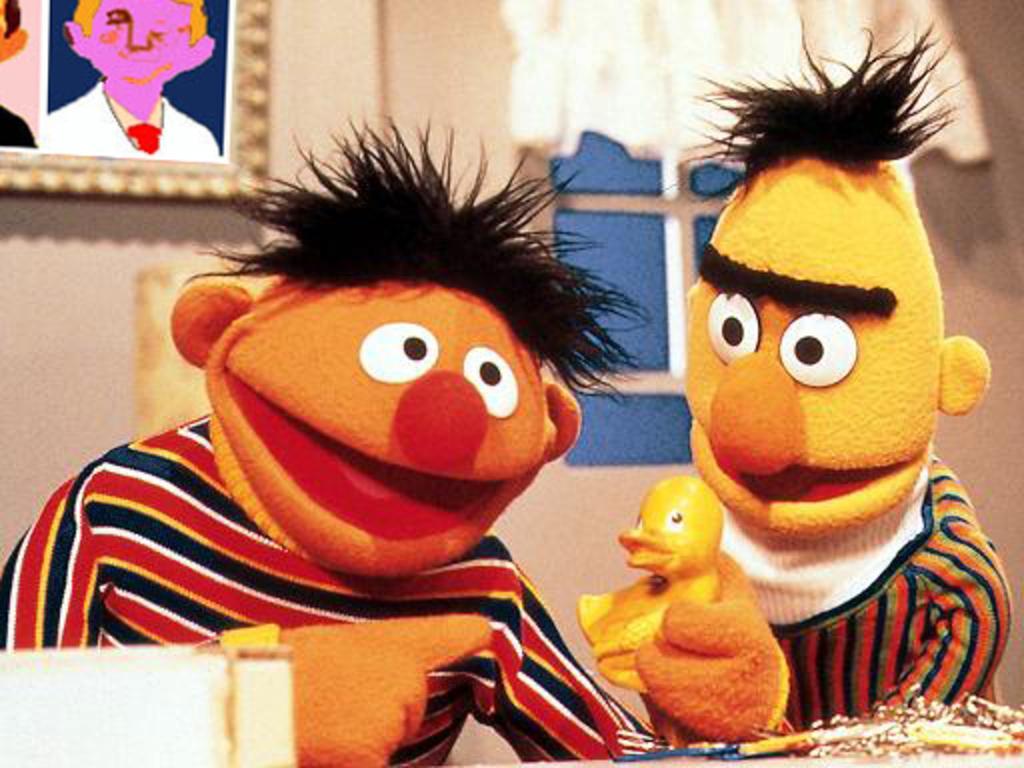How would you summarize this image in a sentence or two? In this image, we can see some people wearing costumes. We can also see a toy. We can see the wall with a window and a white colored object. We can also see the photo frame. We can see an object on the bottom left. 